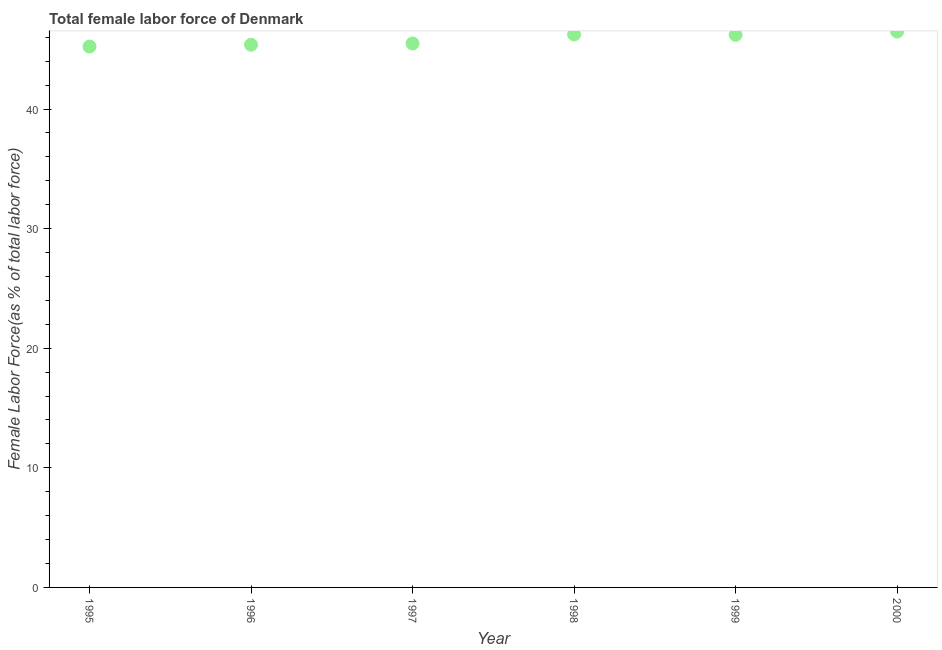What is the total female labor force in 1999?
Your answer should be very brief. 46.2. Across all years, what is the maximum total female labor force?
Give a very brief answer. 46.47. Across all years, what is the minimum total female labor force?
Your answer should be compact. 45.22. In which year was the total female labor force maximum?
Provide a short and direct response. 2000. In which year was the total female labor force minimum?
Your answer should be compact. 1995. What is the sum of the total female labor force?
Provide a succinct answer. 274.98. What is the difference between the total female labor force in 1995 and 1996?
Your answer should be compact. -0.15. What is the average total female labor force per year?
Make the answer very short. 45.83. What is the median total female labor force?
Provide a succinct answer. 45.84. Do a majority of the years between 1999 and 1996 (inclusive) have total female labor force greater than 34 %?
Make the answer very short. Yes. What is the ratio of the total female labor force in 1998 to that in 1999?
Your response must be concise. 1. Is the total female labor force in 1998 less than that in 2000?
Your response must be concise. Yes. Is the difference between the total female labor force in 1998 and 1999 greater than the difference between any two years?
Make the answer very short. No. What is the difference between the highest and the second highest total female labor force?
Offer a terse response. 0.24. What is the difference between the highest and the lowest total female labor force?
Offer a very short reply. 1.25. In how many years, is the total female labor force greater than the average total female labor force taken over all years?
Provide a short and direct response. 3. How many dotlines are there?
Provide a succinct answer. 1. Does the graph contain any zero values?
Make the answer very short. No. What is the title of the graph?
Make the answer very short. Total female labor force of Denmark. What is the label or title of the Y-axis?
Offer a very short reply. Female Labor Force(as % of total labor force). What is the Female Labor Force(as % of total labor force) in 1995?
Offer a terse response. 45.22. What is the Female Labor Force(as % of total labor force) in 1996?
Ensure brevity in your answer.  45.37. What is the Female Labor Force(as % of total labor force) in 1997?
Offer a very short reply. 45.48. What is the Female Labor Force(as % of total labor force) in 1998?
Make the answer very short. 46.23. What is the Female Labor Force(as % of total labor force) in 1999?
Provide a short and direct response. 46.2. What is the Female Labor Force(as % of total labor force) in 2000?
Offer a very short reply. 46.47. What is the difference between the Female Labor Force(as % of total labor force) in 1995 and 1996?
Your answer should be compact. -0.15. What is the difference between the Female Labor Force(as % of total labor force) in 1995 and 1997?
Offer a terse response. -0.26. What is the difference between the Female Labor Force(as % of total labor force) in 1995 and 1998?
Keep it short and to the point. -1.01. What is the difference between the Female Labor Force(as % of total labor force) in 1995 and 1999?
Offer a very short reply. -0.98. What is the difference between the Female Labor Force(as % of total labor force) in 1995 and 2000?
Offer a terse response. -1.25. What is the difference between the Female Labor Force(as % of total labor force) in 1996 and 1997?
Ensure brevity in your answer.  -0.11. What is the difference between the Female Labor Force(as % of total labor force) in 1996 and 1998?
Keep it short and to the point. -0.86. What is the difference between the Female Labor Force(as % of total labor force) in 1996 and 1999?
Your response must be concise. -0.83. What is the difference between the Female Labor Force(as % of total labor force) in 1996 and 2000?
Offer a very short reply. -1.1. What is the difference between the Female Labor Force(as % of total labor force) in 1997 and 1998?
Make the answer very short. -0.75. What is the difference between the Female Labor Force(as % of total labor force) in 1997 and 1999?
Your answer should be compact. -0.72. What is the difference between the Female Labor Force(as % of total labor force) in 1997 and 2000?
Ensure brevity in your answer.  -0.99. What is the difference between the Female Labor Force(as % of total labor force) in 1998 and 1999?
Make the answer very short. 0.03. What is the difference between the Female Labor Force(as % of total labor force) in 1998 and 2000?
Make the answer very short. -0.24. What is the difference between the Female Labor Force(as % of total labor force) in 1999 and 2000?
Offer a very short reply. -0.27. What is the ratio of the Female Labor Force(as % of total labor force) in 1995 to that in 2000?
Give a very brief answer. 0.97. What is the ratio of the Female Labor Force(as % of total labor force) in 1996 to that in 1998?
Provide a succinct answer. 0.98. What is the ratio of the Female Labor Force(as % of total labor force) in 1996 to that in 1999?
Make the answer very short. 0.98. What is the ratio of the Female Labor Force(as % of total labor force) in 1996 to that in 2000?
Your answer should be very brief. 0.98. What is the ratio of the Female Labor Force(as % of total labor force) in 1997 to that in 1998?
Your answer should be compact. 0.98. What is the ratio of the Female Labor Force(as % of total labor force) in 1997 to that in 2000?
Ensure brevity in your answer.  0.98. What is the ratio of the Female Labor Force(as % of total labor force) in 1998 to that in 2000?
Make the answer very short. 0.99. What is the ratio of the Female Labor Force(as % of total labor force) in 1999 to that in 2000?
Provide a short and direct response. 0.99. 